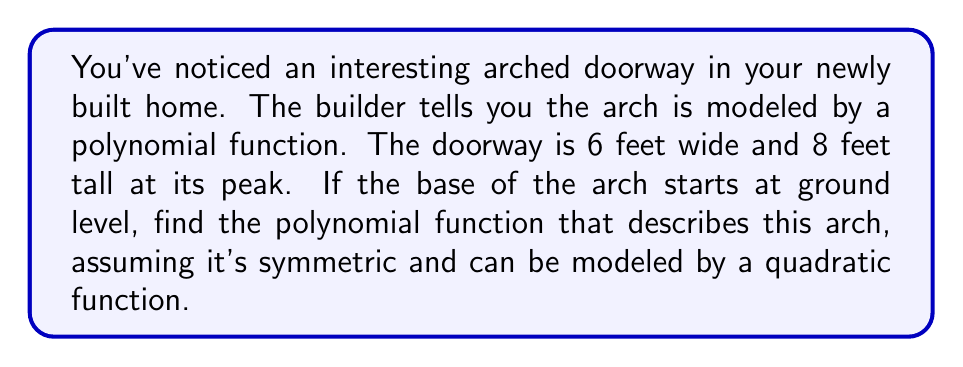Show me your answer to this math problem. Let's approach this step-by-step:

1) We can model this arch using a quadratic function in the form:
   $$ f(x) = a(x-h)^2 + k $$
   where $(h,k)$ is the vertex of the parabola.

2) Given the symmetry, the vertex will be at the center of the doorway horizontally and at the top vertically. So:
   $h = 3$ (half of 6 feet width)
   $k = 8$ (the peak height)

3) Our function is now:
   $$ f(x) = a(x-3)^2 + 8 $$

4) To find $a$, we can use the fact that the arch starts at ground level. This means when $x = 0$, $f(x) = 0$:

   $$ 0 = a(0-3)^2 + 8 $$
   $$ 0 = 9a + 8 $$
   $$ -8 = 9a $$
   $$ a = -\frac{8}{9} $$

5) Therefore, our final function is:
   $$ f(x) = -\frac{8}{9}(x-3)^2 + 8 $$

6) We can expand this to standard form:
   $$ f(x) = -\frac{8}{9}(x^2 - 6x + 9) + 8 $$
   $$ f(x) = -\frac{8}{9}x^2 + \frac{16}{3}x - 8 + 8 $$
   $$ f(x) = -\frac{8}{9}x^2 + \frac{16}{3}x $$

[asy]
import graph;
size(200,200);
real f(real x) {return -8/9*x^2 + 16/3*x;}
draw(graph(f,0,6),blue);
draw((0,0)--(6,0)--(6,8)--(0,8)--cycle);
label("6 ft",((0,0)--(6,0)),S);
label("8 ft",(6,0)--(6,8),E);
[/asy]
Answer: $f(x) = -\frac{8}{9}x^2 + \frac{16}{3}x$ 